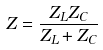<formula> <loc_0><loc_0><loc_500><loc_500>Z = \frac { Z _ { L } Z _ { C } } { Z _ { L } + Z _ { C } }</formula> 